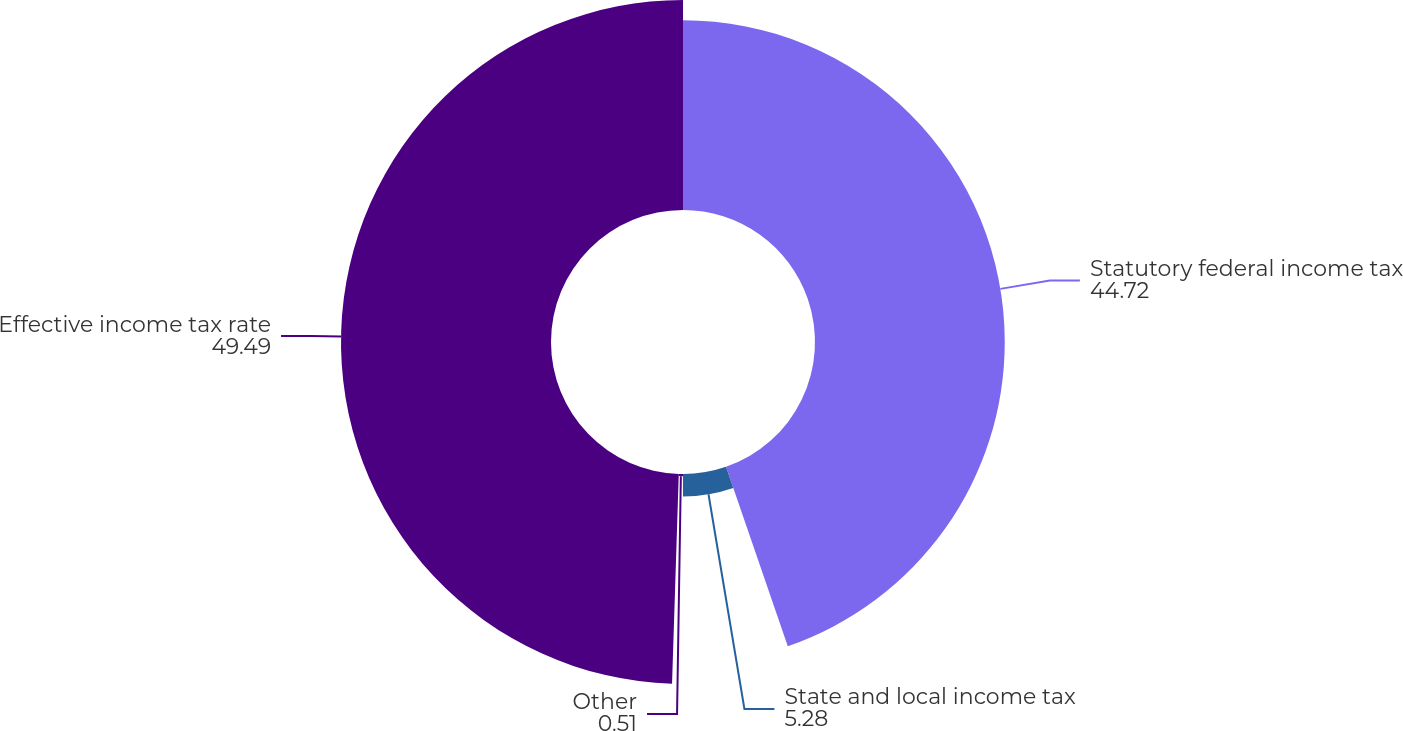Convert chart to OTSL. <chart><loc_0><loc_0><loc_500><loc_500><pie_chart><fcel>Statutory federal income tax<fcel>State and local income tax<fcel>Other<fcel>Effective income tax rate<nl><fcel>44.72%<fcel>5.28%<fcel>0.51%<fcel>49.49%<nl></chart> 